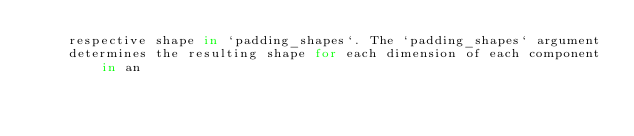Convert code to text. <code><loc_0><loc_0><loc_500><loc_500><_Python_>    respective shape in `padding_shapes`. The `padding_shapes` argument
    determines the resulting shape for each dimension of each component in an</code> 